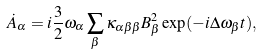<formula> <loc_0><loc_0><loc_500><loc_500>\dot { A } _ { \alpha } = i \frac { 3 } { 2 } \omega _ { \alpha } \sum _ { \beta } \kappa _ { \alpha \beta \beta } B _ { \beta } ^ { 2 } \exp ( - i \Delta \omega _ { \beta } t ) ,</formula> 